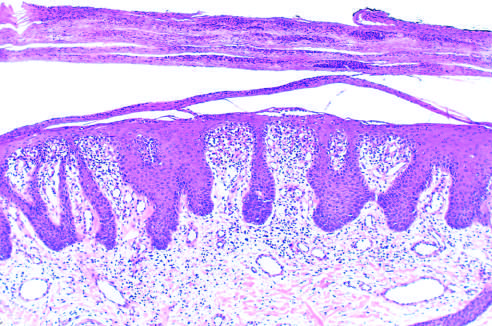does microscopic examination show marked epidermal hyperplasia, downward extension of rete ridges, and prominent parakeratotic scale with infiltrating neutrophils?
Answer the question using a single word or phrase. Yes 